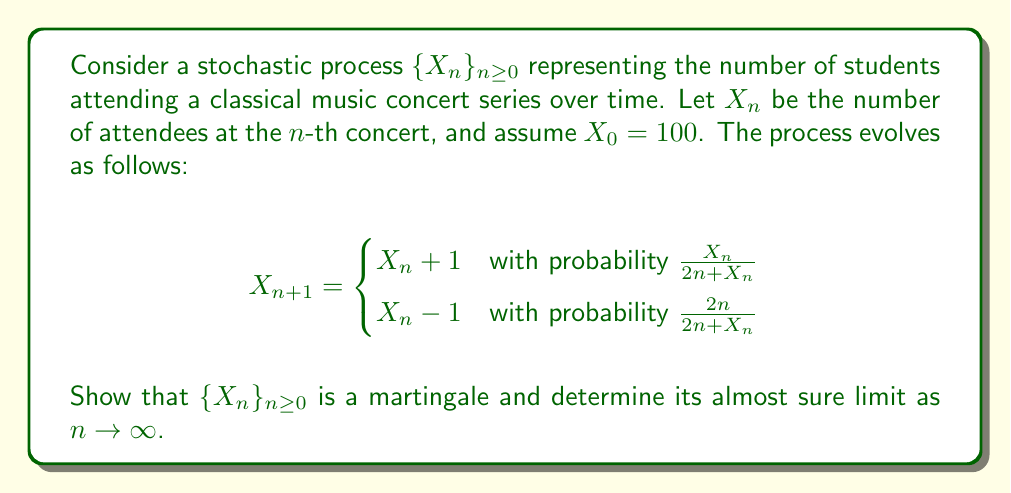Help me with this question. To solve this problem, we'll follow these steps:

1) First, we need to prove that $\{X_n\}_{n \geq 0}$ is a martingale.
2) Then, we'll use the Martingale Convergence Theorem to determine its almost sure limit.

Step 1: Proving $\{X_n\}_{n \geq 0}$ is a martingale

For a process to be a martingale, it must satisfy:
$$E[X_{n+1} | X_n, X_{n-1}, ..., X_0] = X_n$$

Let's calculate $E[X_{n+1} | X_n]$:

$$\begin{align*}
E[X_{n+1} | X_n] &= (X_n + 1) \cdot \frac{X_n}{2n + X_n} + (X_n - 1) \cdot \frac{2n}{2n + X_n} \\
&= \frac{X_n^2 + X_n}{2n + X_n} + \frac{2nX_n - 2n}{2n + X_n} \\
&= \frac{X_n^2 + X_n + 2nX_n - 2n}{2n + X_n} \\
&= \frac{X_n(X_n + 2n + 1) - 2n}{2n + X_n} \\
&= X_n
\end{align*}$$

This proves that $\{X_n\}_{n \geq 0}$ is indeed a martingale.

Step 2: Determining the almost sure limit

To determine the almost sure limit, we'll use the Martingale Convergence Theorem. This theorem states that if a martingale is bounded in $L^1$, it converges almost surely to a finite limit.

Let's check if our martingale is bounded in $L^1$:

$$E[|X_n|] \leq E[X_n] = E[X_0] = 100$$

The last equality holds because the expected value of a martingale is constant over time.

Since $\{X_n\}_{n \geq 0}$ is bounded in $L^1$, by the Martingale Convergence Theorem, there exists a random variable $X_\infty$ such that:

$$X_n \xrightarrow{a.s.} X_\infty \text{ as } n \to \infty$$

Moreover, $E[X_\infty] = E[X_0] = 100$.

To determine the exact value of $X_\infty$, we need to consider the behavior of the process as $n \to \infty$:

$$\lim_{n \to \infty} P(X_{n+1} = X_n + 1) = \lim_{n \to \infty} \frac{X_n}{2n + X_n} = 0$$
$$\lim_{n \to \infty} P(X_{n+1} = X_n - 1) = \lim_{n \to \infty} \frac{2n}{2n + X_n} = 1$$

This implies that as $n \to \infty$, the process will almost surely decrease until it reaches 0, at which point it will stay at 0.

Therefore, $X_\infty = 0$ almost surely.
Answer: $X_n \xrightarrow{a.s.} 0$ as $n \to \infty$ 